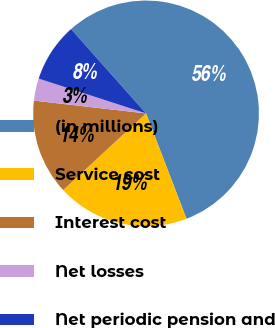Convert chart. <chart><loc_0><loc_0><loc_500><loc_500><pie_chart><fcel>(in millions)<fcel>Service cost<fcel>Interest cost<fcel>Net losses<fcel>Net periodic pension and<nl><fcel>55.74%<fcel>18.95%<fcel>13.69%<fcel>3.18%<fcel>8.44%<nl></chart> 